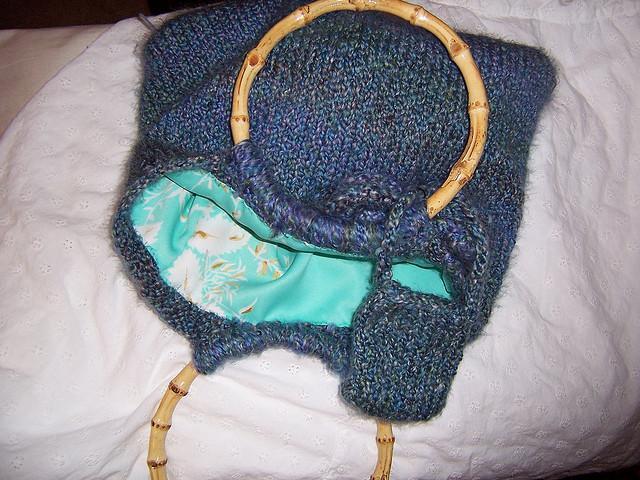How many bunches of bananas are in this picture?
Give a very brief answer. 0. 